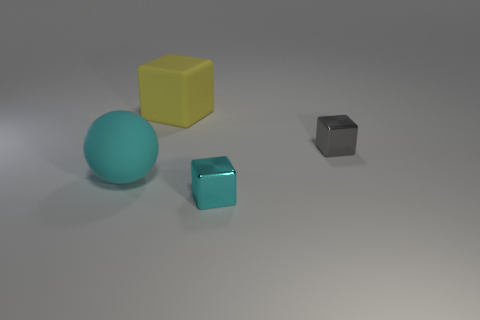Is there a shiny cube of the same color as the big sphere?
Provide a succinct answer. Yes. There is a shiny object that is the same color as the large matte sphere; what is its size?
Provide a succinct answer. Small. The matte thing that is in front of the gray thing has what shape?
Provide a succinct answer. Sphere. What is the shape of the yellow object that is the same material as the big sphere?
Keep it short and to the point. Cube. How many rubber objects are big cyan objects or blocks?
Ensure brevity in your answer.  2. What number of metallic things are right of the tiny metallic object in front of the small object that is behind the cyan matte ball?
Give a very brief answer. 1. There is a object that is on the left side of the yellow matte cube; does it have the same size as the cyan thing that is on the right side of the yellow thing?
Provide a short and direct response. No. There is a gray thing that is the same shape as the yellow matte thing; what material is it?
Ensure brevity in your answer.  Metal. How many large things are either blocks or cyan objects?
Provide a short and direct response. 2. What is the material of the small cyan object?
Ensure brevity in your answer.  Metal. 